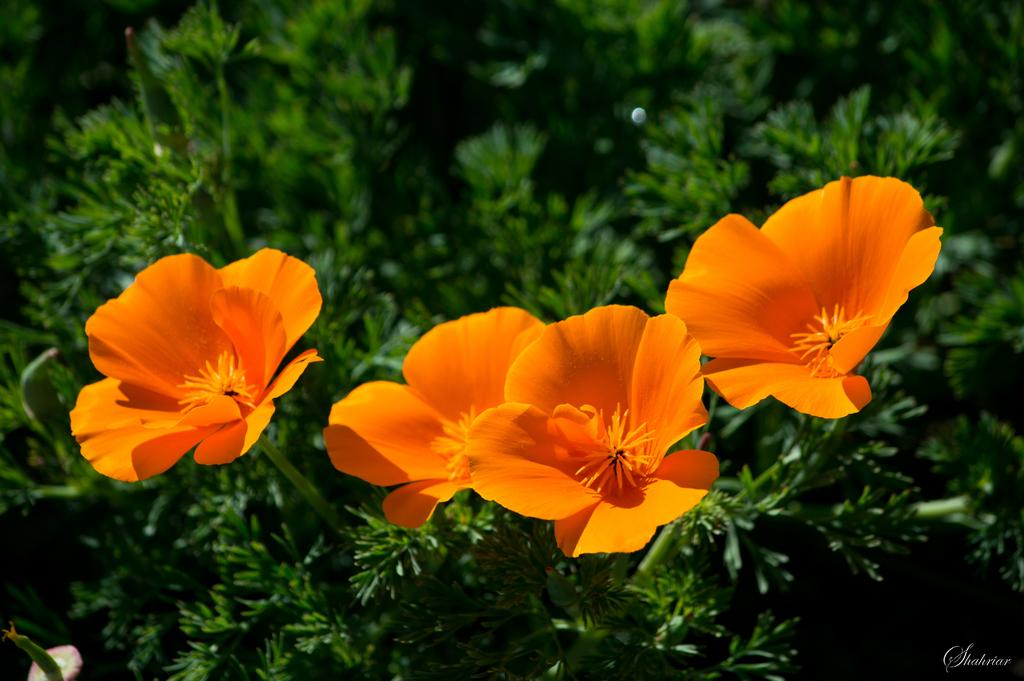What type of plants can be seen in the image? There are flower plants in the image. Where is the text located in the image? The text is in the bottom right corner of the image. How many rings are visible on the pet in the image? There is no pet present in the image, and therefore no rings can be observed. 